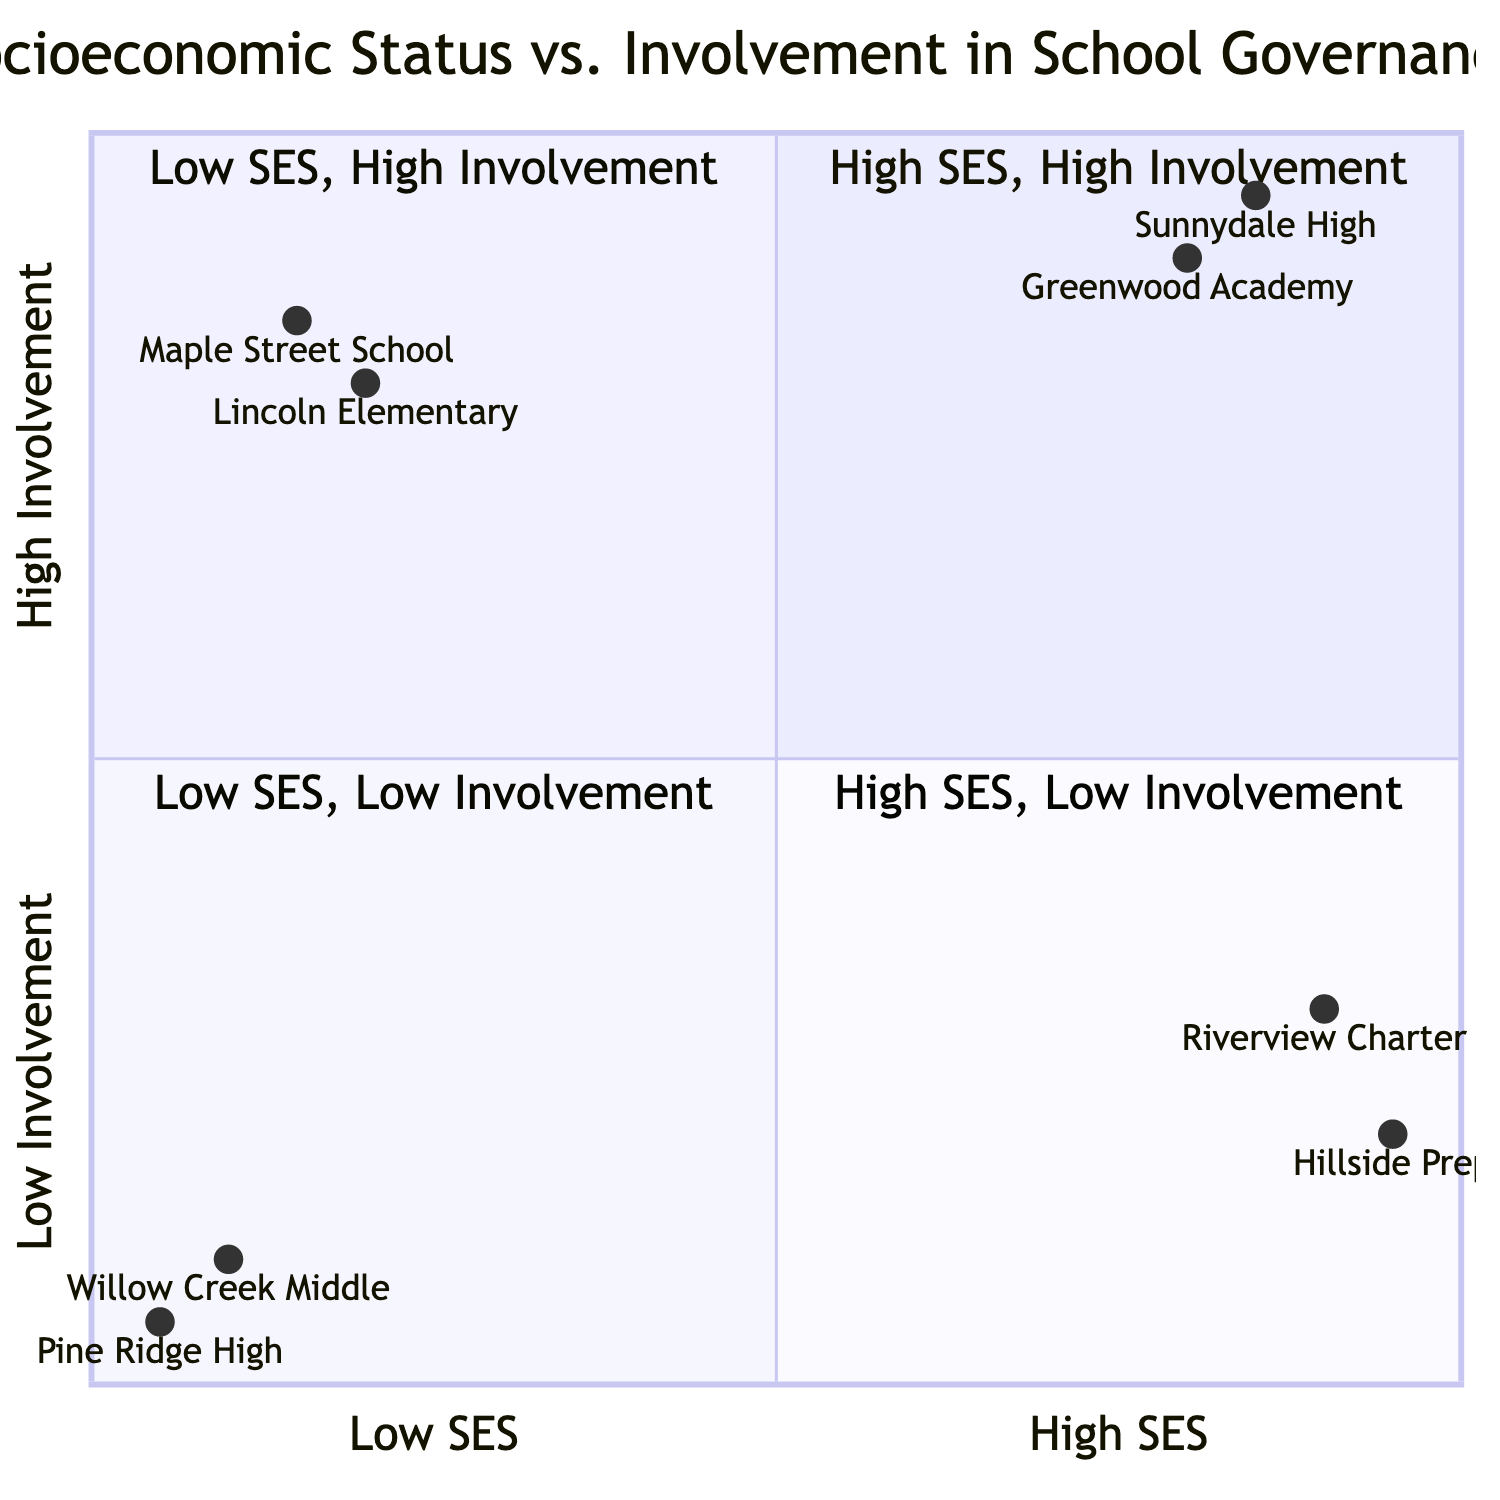What schools are in the High SES, High Involvement quadrant? The High SES, High Involvement quadrant contains two schools: Greenwood Academy and Sunnydale High. These schools are positioned in the upper right corner of the quadrant chart, indicating both high socioeconomic status and high parental involvement.
Answer: Greenwood Academy, Sunnydale High What is the involvement level of Riverview Charter School? Riverview Charter School is located in the High SES, Low Involvement quadrant. Its position confirms a high socioeconomic status but a low level of parental involvement in school governance.
Answer: Low Involvement How many schools are represented in the Low SES, Low Involvement quadrant? The Low SES, Low Involvement quadrant has two schools: Willow Creek Middle School and Pine Ridge High. This indicates a category of schools with both low socioeconomic status and low engagement of parents.
Answer: 2 Which school has the highest parental involvement? The school with the highest parental involvement is Sunnydale High, which is positioned to the top of the chart, indicating high involvement amongst high socioeconomic status parents.
Answer: Sunnydale High Which quadrant includes both Lincoln Elementary and Maple Street School? Both Lincoln Elementary and Maple Street School are located in the Low SES, High Involvement quadrant. This quadrant shows that these schools have low socioeconomic status but high levels of parental participation in school activities.
Answer: Low SES, High Involvement What barriers to involvement are observed for schools in the Low SES, Low Involvement quadrant? Schools in the Low SES, Low Involvement quadrant, such as Willow Creek Middle School and Pine Ridge High, face barriers like work schedules, transportation issues, and lack of awareness, which limit parental engagement.
Answer: Barriers include work schedules, transportation issues Which quadrant has parents that mainly support schools through funding? The High SES, Low Involvement quadrant includes parents who support schools primarily through funding, as seen in Riverview Charter School where there's low physical presence of parents in school governance activities.
Answer: High SES, Low Involvement How does socioeconomic status affect parental involvement in governance? Generally, the quadrant chart illustrates that high socioeconomic status correlates with higher parental involvement in school governance. This is evident in the High SES, High Involvement quadrant compared to the Low SES, Low Involvement quadrant.
Answer: Positive correlation What characteristics are shared by schools in the Low SES, High Involvement quadrant? Schools in the Low SES, High Involvement quadrant share characteristics of active parental participation and community resource leverage, despite their limited financial resources, as seen in Lincoln Elementary and Maple Street School.
Answer: Active participation, community resource leverage 